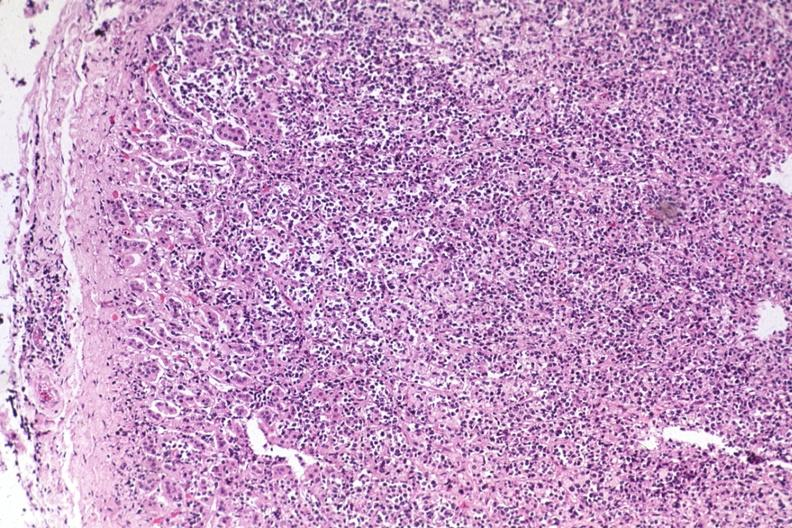where is this part in the figure?
Answer the question using a single word or phrase. Endocrine system 